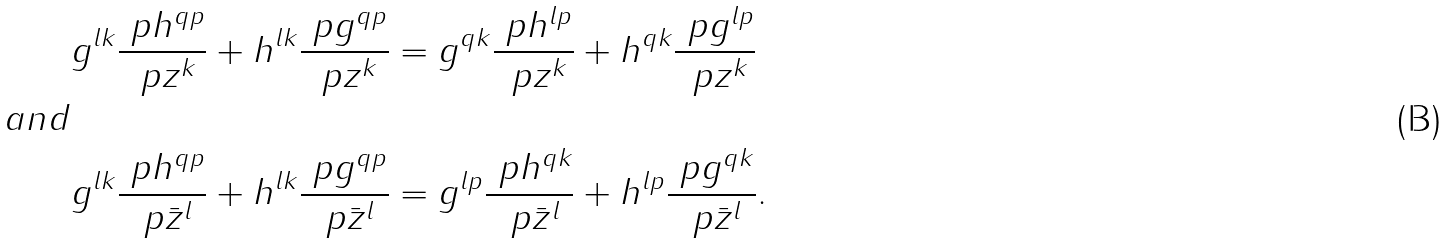<formula> <loc_0><loc_0><loc_500><loc_500>& g ^ { l k } \frac { \ p h ^ { q p } } { \ p z ^ { k } } + h ^ { l k } \frac { \ p g ^ { q p } } { \ p z ^ { k } } = g ^ { q k } \frac { \ p h ^ { l p } } { \ p z ^ { k } } + h ^ { q k } \frac { \ p g ^ { l p } } { \ p z ^ { k } } \\ a n d & \\ & g ^ { l k } \frac { \ p h ^ { q p } } { \ p \bar { z } ^ { l } } + h ^ { l k } \frac { \ p g ^ { q p } } { \ p \bar { z } ^ { l } } = g ^ { l p } \frac { \ p h ^ { q k } } { \ p \bar { z } ^ { l } } + h ^ { l p } \frac { \ p g ^ { q k } } { \ p \bar { z } ^ { l } } .</formula> 